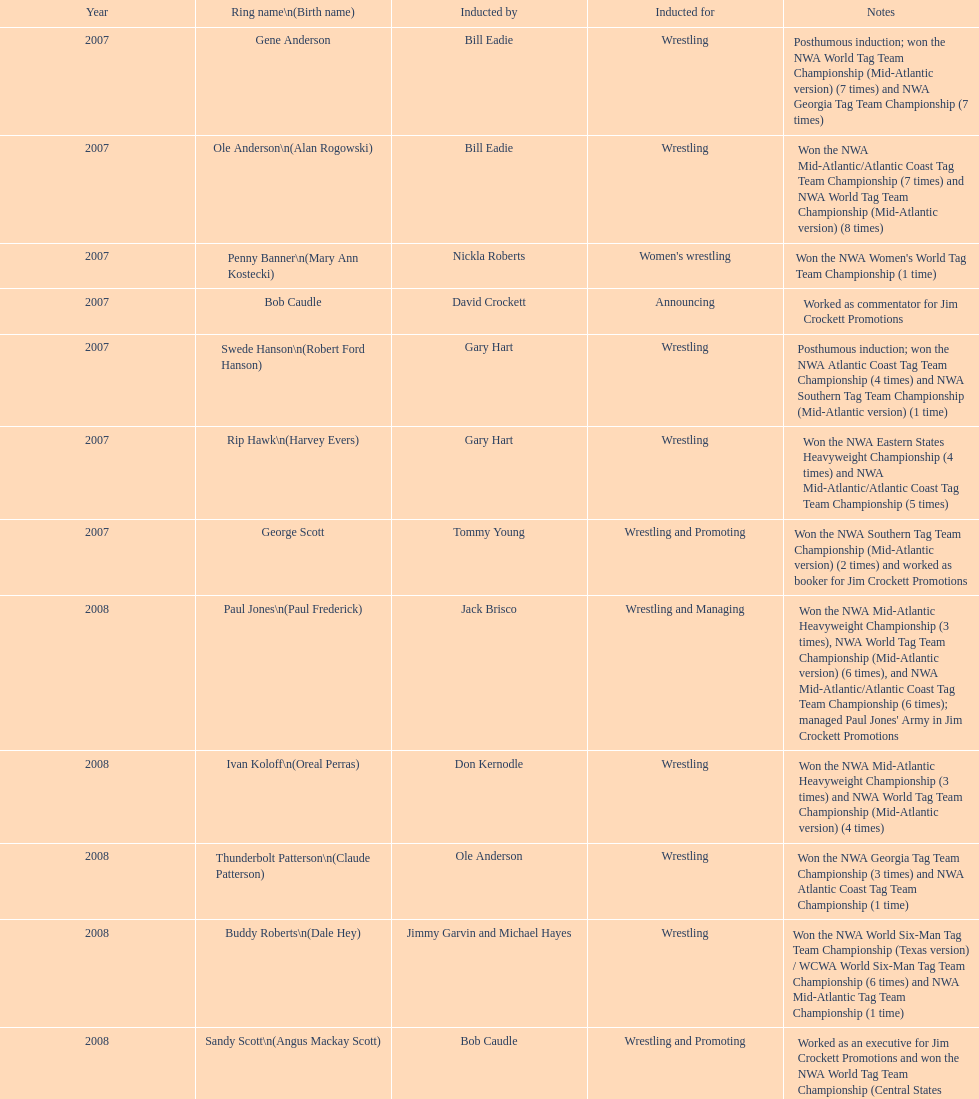Who holds the record for the most nwa southern tag team wins (mid-america version)? Jackie Fargo. 